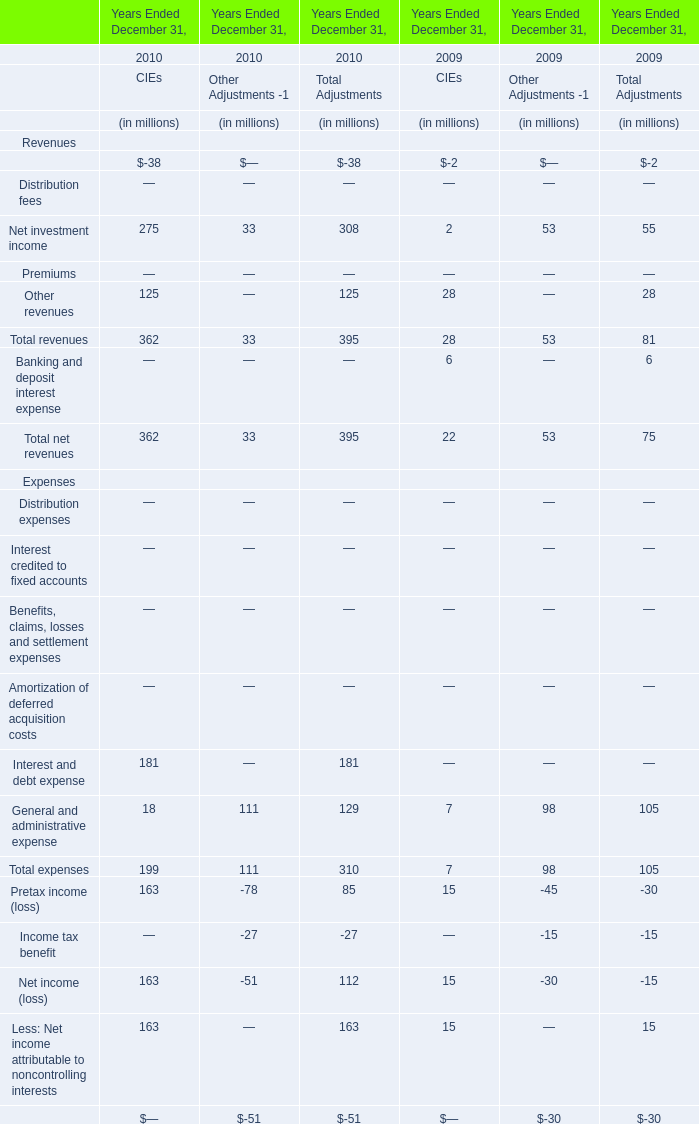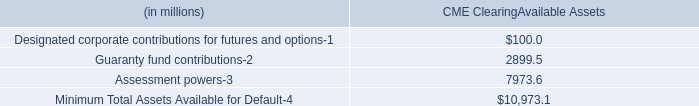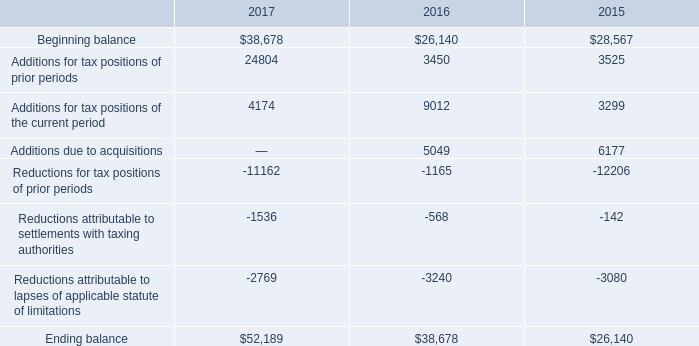What is the growing rate of Net investment income of CIEs in table 0 in the year with the least Management and financial advice fees of CIEs in table 0? 
Computations: ((275 - 2) / 2)
Answer: 136.5. 